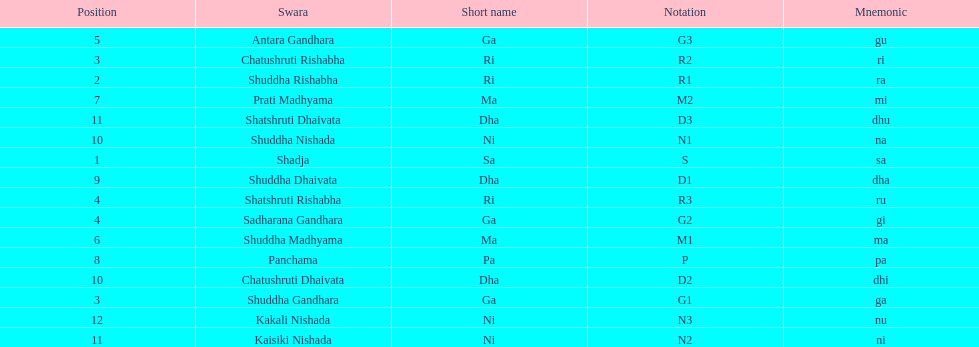What swara is above shatshruti dhaivata? Shuddha Nishada. 